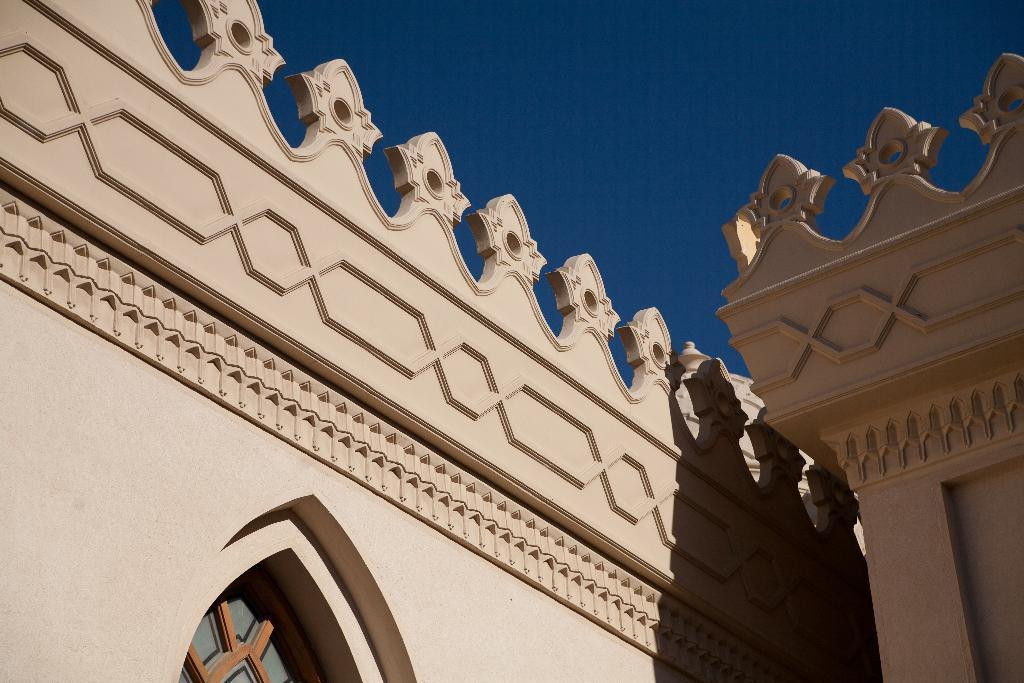What is the main subject of the image? The main subject of the image is a building wall. Can you describe the design on the building wall? Yes, there is a design on the building wall. What architectural feature can be seen in the image? There is a window in the image. What is visible in the background of the image? The sky is visible in the background of the image. How many attempts were made to deliver the parcel in the image? There is no parcel or delivery attempt present in the image. What type of juice is being served in the image? There is no juice or serving of juice present in the image. 